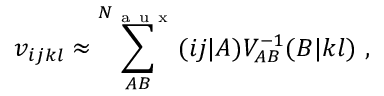Convert formula to latex. <formula><loc_0><loc_0><loc_500><loc_500>v _ { i j k l } \approx \sum _ { A B } ^ { N _ { a u x } } ( i j | A ) V _ { A B } ^ { - 1 } ( B | k l ) ,</formula> 